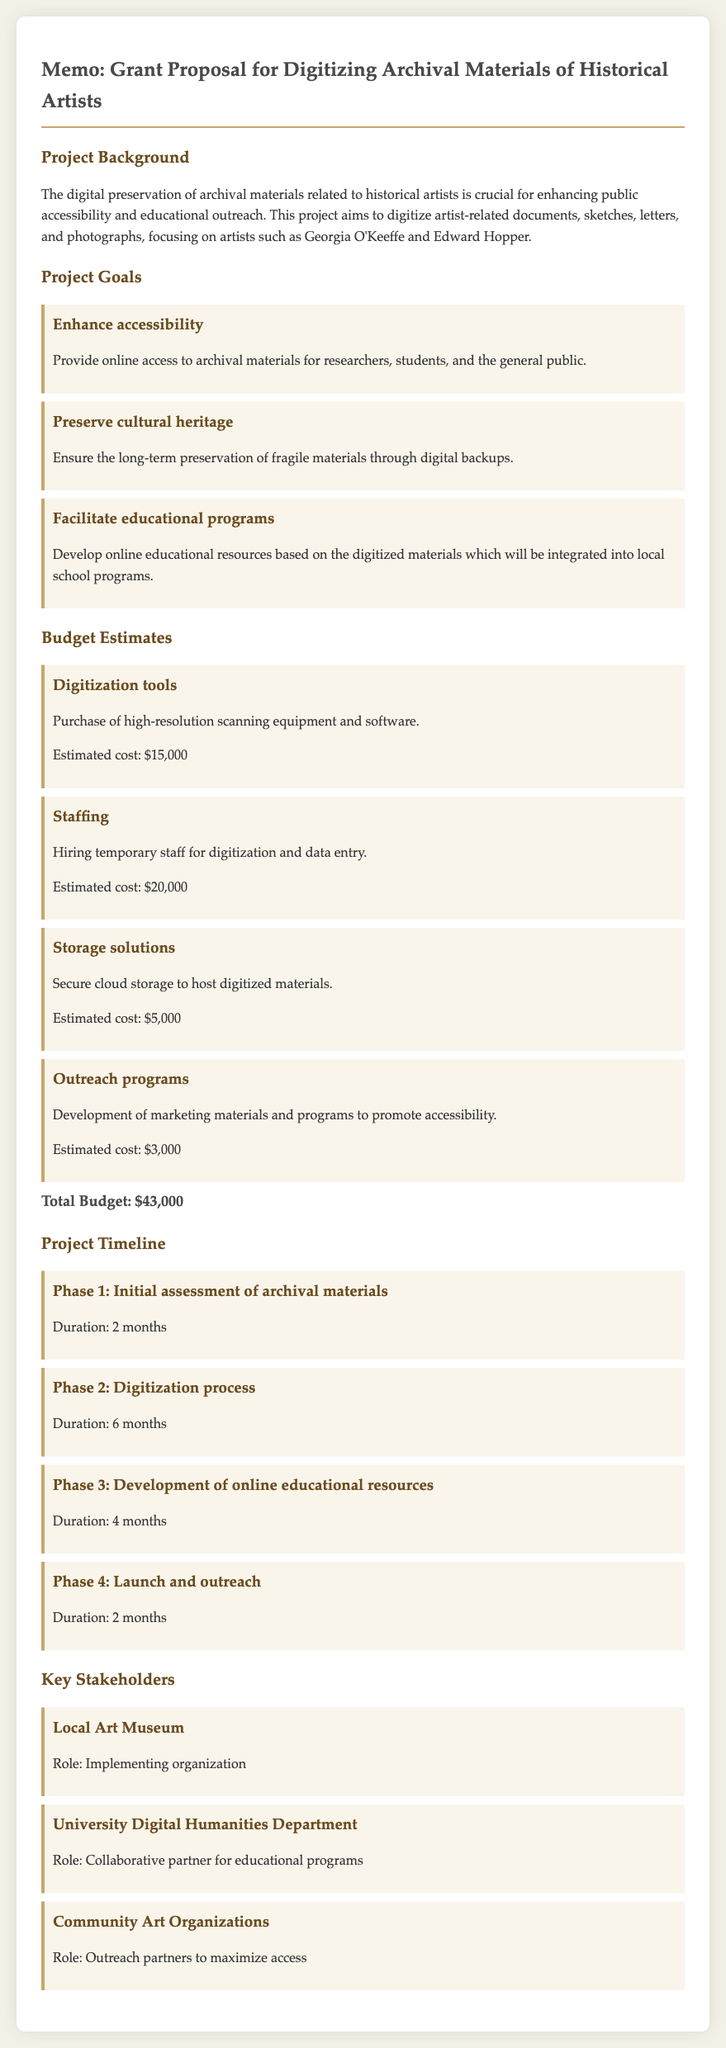what is the total budget? The total budget is calculated by summing up all estimated costs listed in the budget estimates section.
Answer: $43,000 how long is the digitization process? The duration of the digitization process is specified in the project timeline section of the document.
Answer: 6 months who is the implementing organization? The memo states the role of the local art museum in the key stakeholders section.
Answer: Local Art Museum what is one of the project goals? The document lists multiple goals in the project goals section; any of them can be a valid answer.
Answer: Enhance accessibility what is the estimated cost for storage solutions? The estimated cost for storage solutions is provided in the budget estimates section.
Answer: $5,000 what is the duration of the outreach phase? The duration of the outreach phase can be found in the project timeline section.
Answer: 2 months who collaborates on educational programs? The university digital humanities department's role is mentioned regarding collaboration in the key stakeholders section.
Answer: University Digital Humanities Department what equipment is needed for digitization? The memo specifies that high-resolution scanning equipment is part of the budget estimates under digitization tools.
Answer: High-resolution scanning equipment 